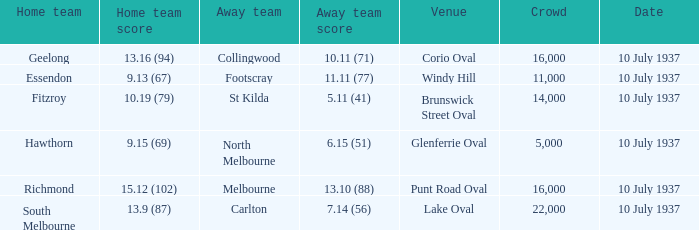What was the lowest Crowd during the Away Team Score of 10.11 (71)? 16000.0. 